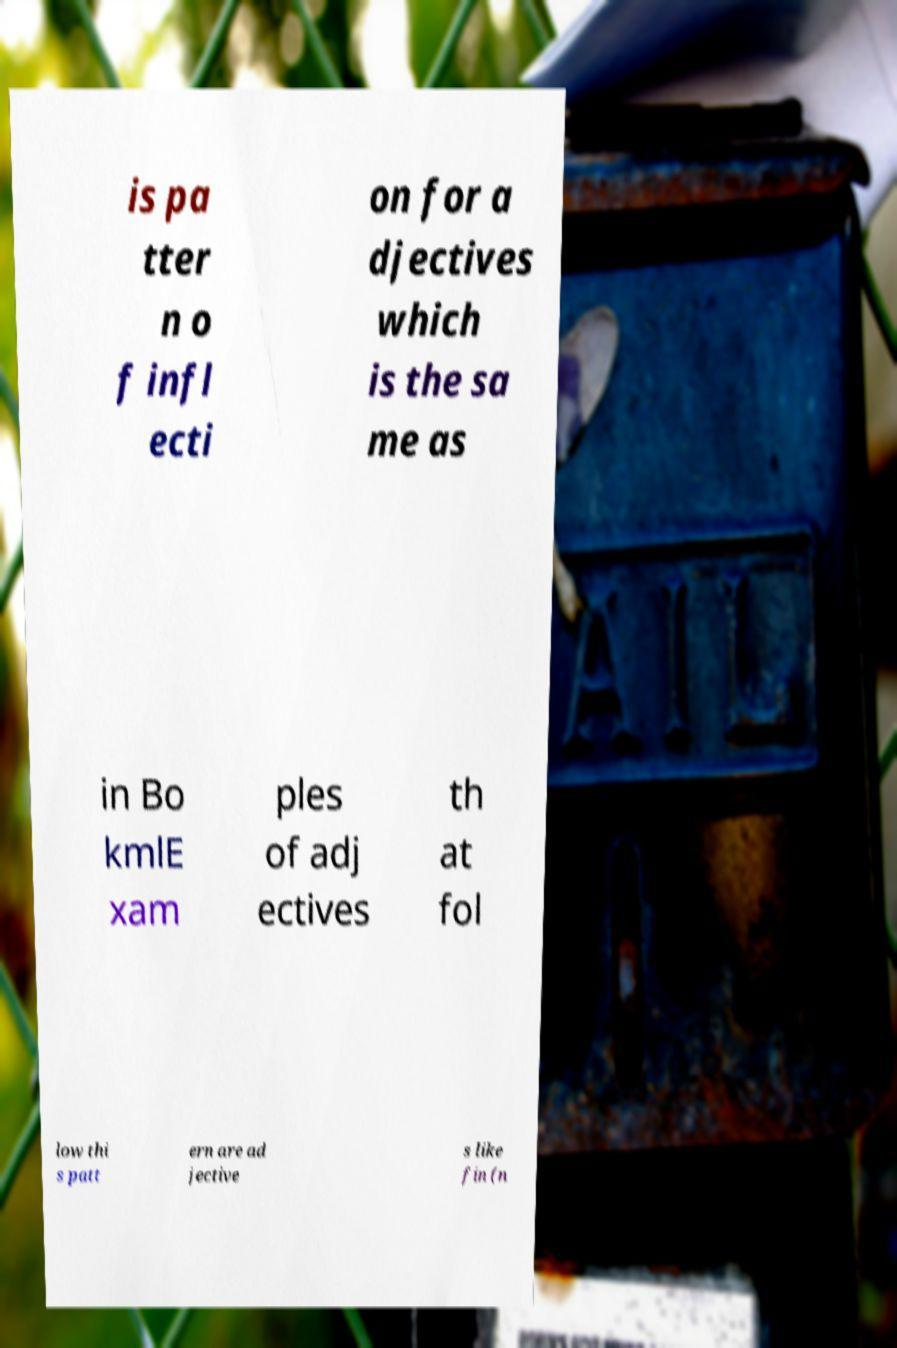Can you read and provide the text displayed in the image?This photo seems to have some interesting text. Can you extract and type it out for me? is pa tter n o f infl ecti on for a djectives which is the sa me as in Bo kmlE xam ples of adj ectives th at fol low thi s patt ern are ad jective s like fin (n 